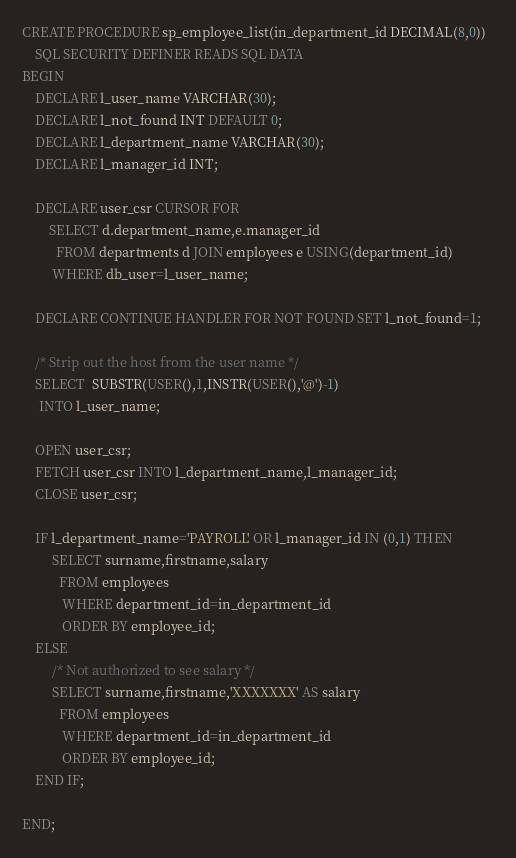Convert code to text. <code><loc_0><loc_0><loc_500><loc_500><_SQL_>CREATE PROCEDURE sp_employee_list(in_department_id DECIMAL(8,0))
	SQL SECURITY DEFINER READS SQL DATA
BEGIN
	DECLARE l_user_name VARCHAR(30);
	DECLARE l_not_found INT DEFAULT 0;
	DECLARE l_department_name VARCHAR(30);
	DECLARE l_manager_id INT;
	
	DECLARE user_csr CURSOR FOR 
		SELECT d.department_name,e.manager_id 
		  FROM departments d JOIN employees e USING(department_id)
		 WHERE db_user=l_user_name;
		
	DECLARE CONTINUE HANDLER FOR NOT FOUND SET l_not_found=1;	

	/* Strip out the host from the user name */
	SELECT  SUBSTR(USER(),1,INSTR(USER(),'@')-1) 
	 INTO l_user_name;
	
	OPEN user_csr;
	FETCH user_csr INTO l_department_name,l_manager_id;
	CLOSE user_csr;
	
	IF l_department_name='PAYROLL' OR l_manager_id IN (0,1) THEN 
		 SELECT surname,firstname,salary 
		   FROM employees 
			WHERE department_id=in_department_id 
			ORDER BY employee_id;
	ELSE
		 /* Not authorized to see salary */
		 SELECT surname,firstname,'XXXXXXX' AS salary 
		   FROM employees 
			WHERE department_id=in_department_id 
			ORDER BY employee_id; 
	END IF;
		
END;
</code> 